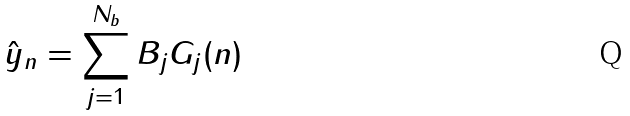<formula> <loc_0><loc_0><loc_500><loc_500>\hat { y } _ { n } = \sum _ { j = 1 } ^ { N _ { b } } B _ { j } G _ { j } ( n )</formula> 